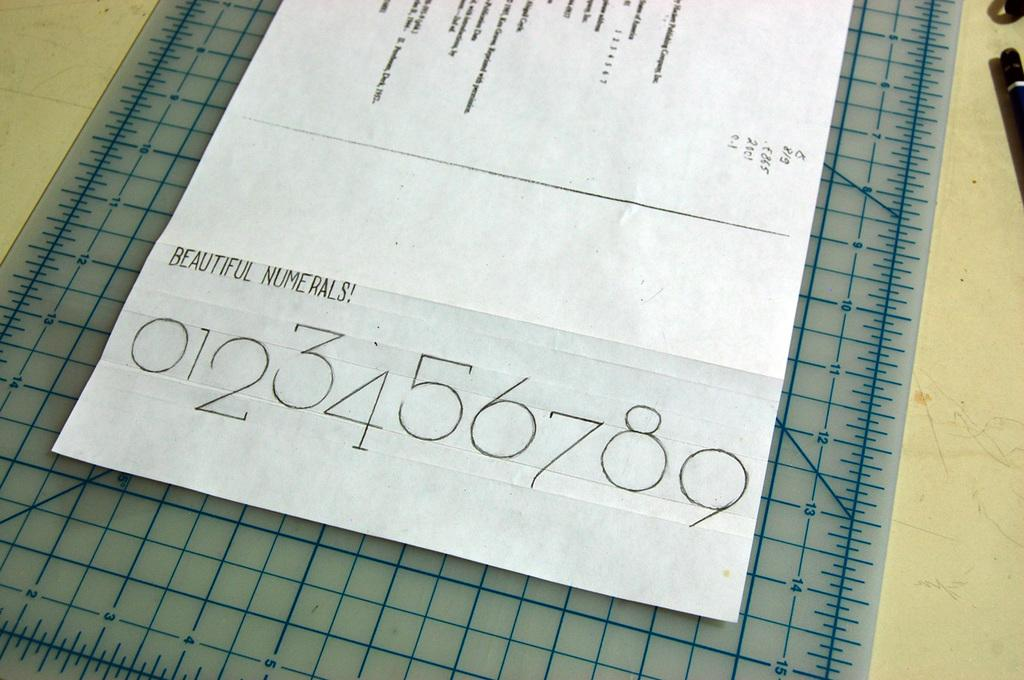<image>
Offer a succinct explanation of the picture presented. Paper is on a cutting board with some numbers under the words beautiful numerals. 